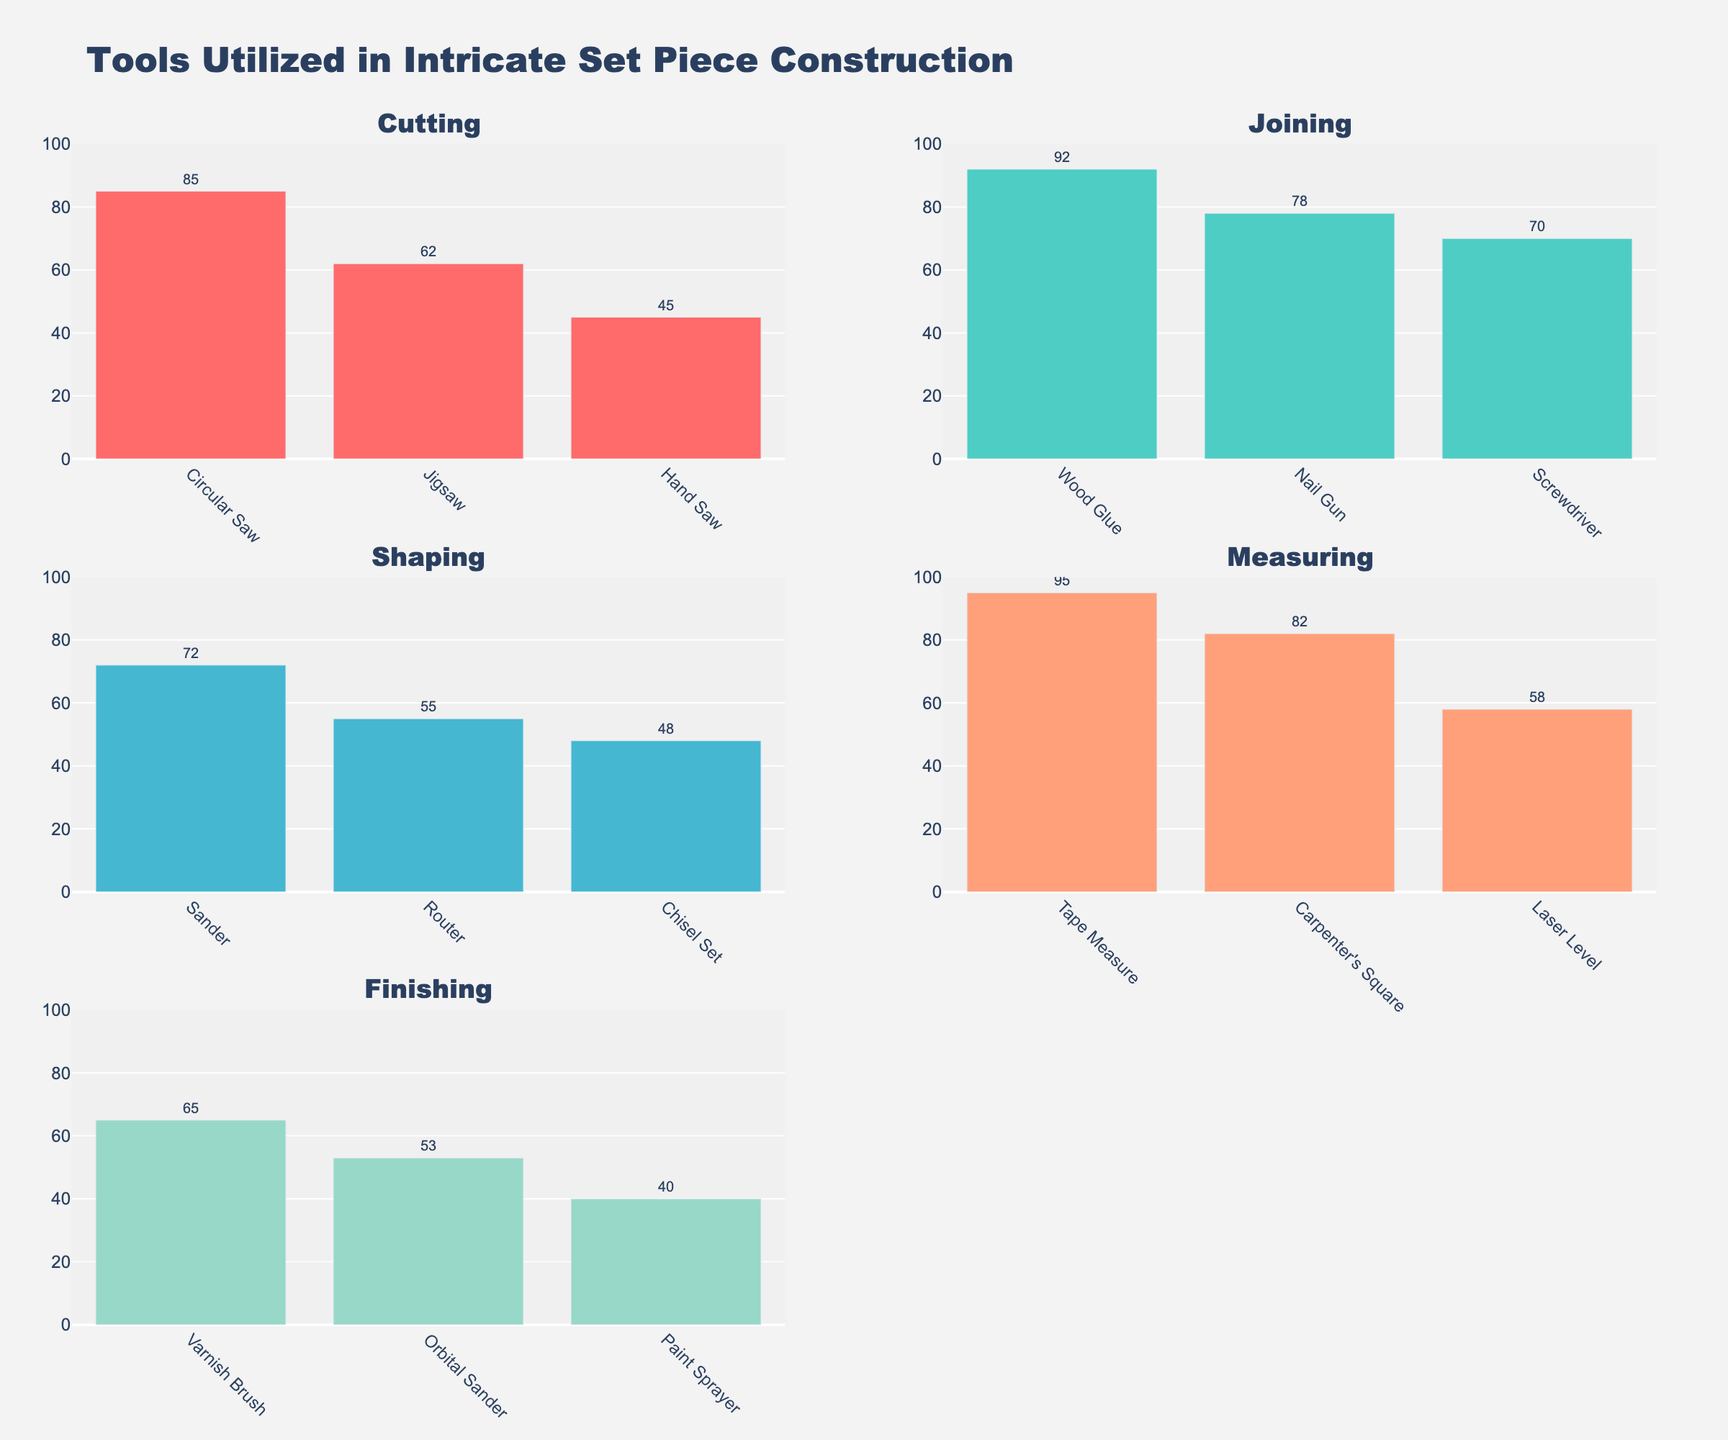What is the title of the figure? The title of the figure is prominently displayed at the top. The title text is "Tools Utilized in Intricate Set Piece Construction."
Answer: Tools Utilized in Intricate Set Piece Construction Which function has the tool with the highest frequency? The Tape Measure tool under the Measuring function has the highest frequency, which is visually indicated as the tallest bar in the entire figure with a value of 95.
Answer: Measuring How many tools are used for shaping? Count the bars under the subplot titled "Shaping" to determine the number of tools. There are three tools: Router, Chisel Set, and Sander.
Answer: 3 Which tool has the lowest frequency and under which function? Identify the shortest bar across all subplots. The Paint Sprayer under the Finishing function has the lowest frequency with a value of 40.
Answer: Paint Sprayer, Finishing What is the total frequency of tools used for the function of joining? Sum the frequencies of the three tools listed under the Joining subplot: Nail Gun (78), Wood Glue (92), and Screwdriver (70). 78 + 92 + 70 = 240
Answer: 240 Which tool in the Cutting function is used the least frequently? Look at the "Cutting" subplot and identify the tool with the shortest bar. Hand Saw is used the least frequently with a frequency of 45.
Answer: Hand Saw Compare the frequency of the Circular Saw and the Jigsaw. Which is used more often? Look at the heights of the bars for Circular Saw and Jigsaw under the Cutting function and compare their frequency values. Circular Saw has a frequency of 85, while Jigsaw has 62, so Circular Saw is used more often.
Answer: Circular Saw What is the average frequency of tools used in the Finishing function? Sum the frequencies of all tools used in Finishing and then divide by the number of tools. (40 + 65 + 53) / 3 = 158 / 3 = 52.67
Answer: 52.67 Which tool under the Measuring function has a frequency closest to the average of its function's frequencies? Calculate the average frequency of Measuring tools ((Tape Measure) 95 + (Laser Level) 58 + (Carpenter's Square) 82) / 3 = 78.33. Compare the three values to find which is closest to 78.33. Carpenter's Square has a frequency of 82, which is closest to 78.33.
Answer: Carpenter's Square Between the Shaping and Joining functions, which group has the higher total tool frequency? Calculate the total frequency for each function. For Shaping: 55 (Router) + 48 (Chisel Set) + 72 (Sander) = 175. For Joining: 78 (Nail Gun) + 92 (Wood Glue) + 70 (Screwdriver) = 240. Compare the totals; Joining has a higher total frequency.
Answer: Joining 